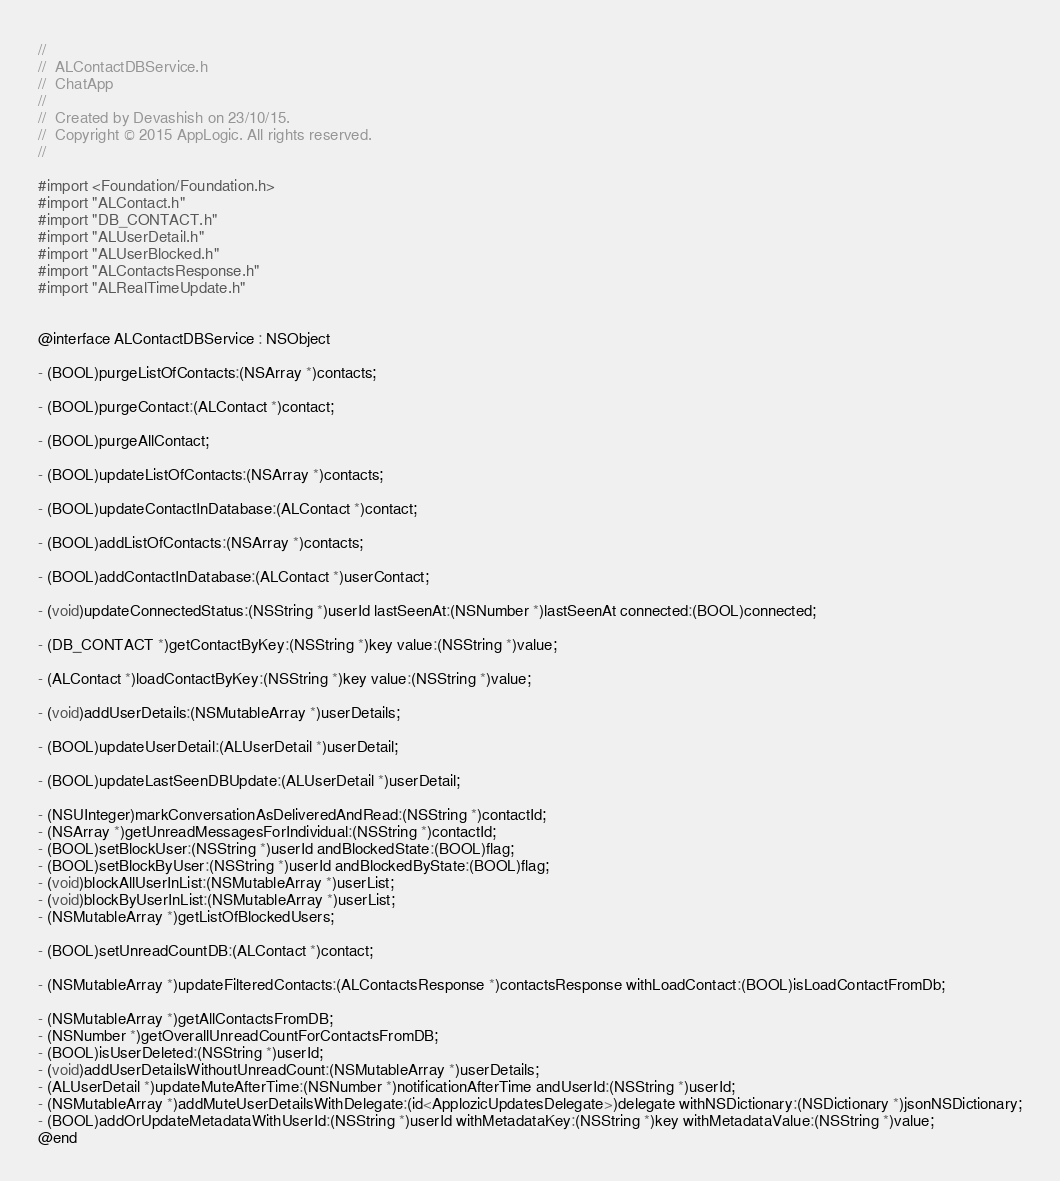Convert code to text. <code><loc_0><loc_0><loc_500><loc_500><_C_>//
//  ALContactDBService.h
//  ChatApp
//
//  Created by Devashish on 23/10/15.
//  Copyright © 2015 AppLogic. All rights reserved.
//

#import <Foundation/Foundation.h>
#import "ALContact.h"
#import "DB_CONTACT.h"
#import "ALUserDetail.h"
#import "ALUserBlocked.h"
#import "ALContactsResponse.h"
#import "ALRealTimeUpdate.h"


@interface ALContactDBService : NSObject

- (BOOL)purgeListOfContacts:(NSArray *)contacts;

- (BOOL)purgeContact:(ALContact *)contact;

- (BOOL)purgeAllContact;

- (BOOL)updateListOfContacts:(NSArray *)contacts;

- (BOOL)updateContactInDatabase:(ALContact *)contact;

- (BOOL)addListOfContacts:(NSArray *)contacts;

- (BOOL)addContactInDatabase:(ALContact *)userContact;

- (void)updateConnectedStatus:(NSString *)userId lastSeenAt:(NSNumber *)lastSeenAt connected:(BOOL)connected;

- (DB_CONTACT *)getContactByKey:(NSString *)key value:(NSString *)value;

- (ALContact *)loadContactByKey:(NSString *)key value:(NSString *)value;

- (void)addUserDetails:(NSMutableArray *)userDetails;

- (BOOL)updateUserDetail:(ALUserDetail *)userDetail;

- (BOOL)updateLastSeenDBUpdate:(ALUserDetail *)userDetail;

- (NSUInteger)markConversationAsDeliveredAndRead:(NSString *)contactId;
- (NSArray *)getUnreadMessagesForIndividual:(NSString *)contactId;
- (BOOL)setBlockUser:(NSString *)userId andBlockedState:(BOOL)flag;
- (BOOL)setBlockByUser:(NSString *)userId andBlockedByState:(BOOL)flag;
- (void)blockAllUserInList:(NSMutableArray *)userList;
- (void)blockByUserInList:(NSMutableArray *)userList;
- (NSMutableArray *)getListOfBlockedUsers;

- (BOOL)setUnreadCountDB:(ALContact *)contact;

- (NSMutableArray *)updateFilteredContacts:(ALContactsResponse *)contactsResponse withLoadContact:(BOOL)isLoadContactFromDb;

- (NSMutableArray *)getAllContactsFromDB;
- (NSNumber *)getOverallUnreadCountForContactsFromDB;
- (BOOL)isUserDeleted:(NSString *)userId;
- (void)addUserDetailsWithoutUnreadCount:(NSMutableArray *)userDetails;
- (ALUserDetail *)updateMuteAfterTime:(NSNumber *)notificationAfterTime andUserId:(NSString *)userId;
- (NSMutableArray *)addMuteUserDetailsWithDelegate:(id<ApplozicUpdatesDelegate>)delegate withNSDictionary:(NSDictionary *)jsonNSDictionary;
- (BOOL)addOrUpdateMetadataWithUserId:(NSString *)userId withMetadataKey:(NSString *)key withMetadataValue:(NSString *)value;
@end
</code> 